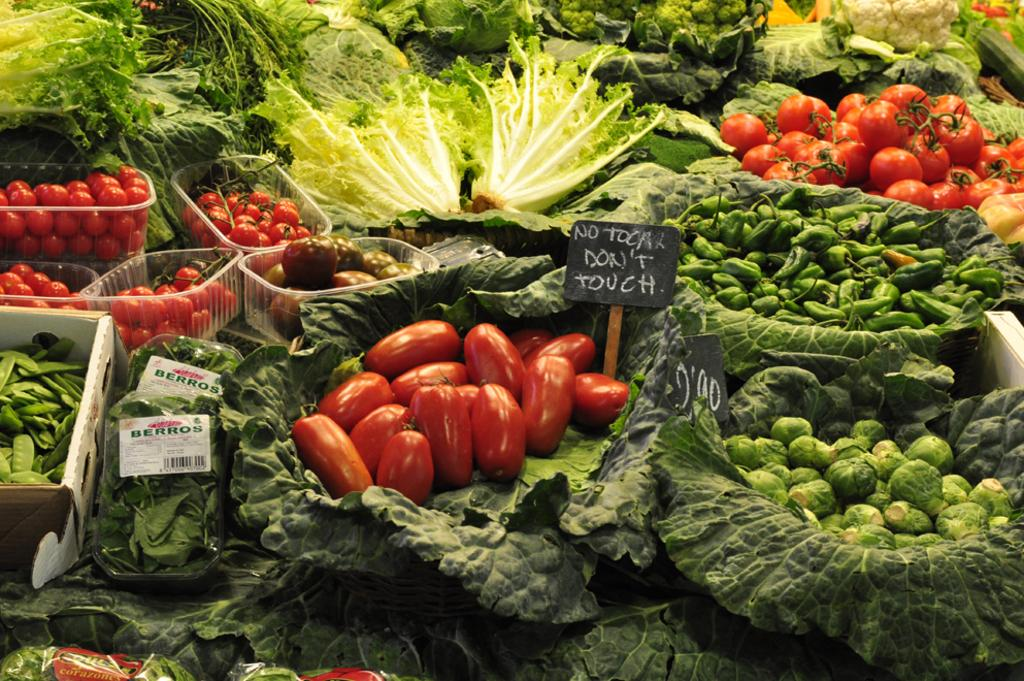What is the focus of the image? The image is zoomed in on tomatoes, chilies, and other vegetables in the center. What are the vegetables placed in? The vegetables are placed in boxes. Are there any other elements in the image besides the vegetables? Yes, there are boards with text in the image. Can you see a desk in the image? No, there is no desk present in the image. Is there a bear visible among the vegetables? No, there is no bear present in the image. 